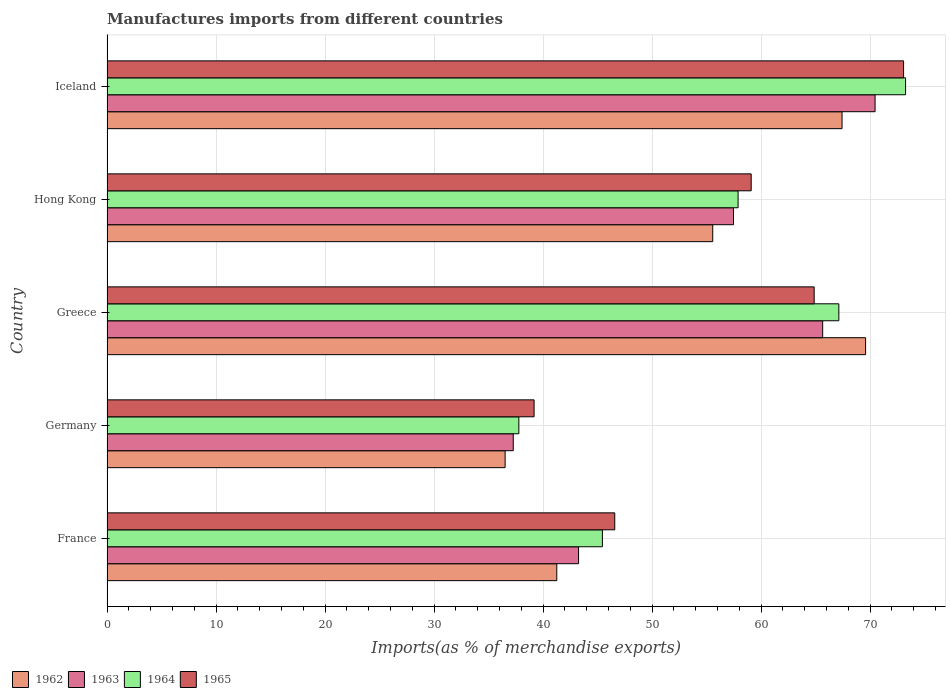How many different coloured bars are there?
Offer a very short reply. 4. How many groups of bars are there?
Provide a succinct answer. 5. Are the number of bars on each tick of the Y-axis equal?
Your response must be concise. Yes. How many bars are there on the 4th tick from the top?
Keep it short and to the point. 4. What is the label of the 2nd group of bars from the top?
Give a very brief answer. Hong Kong. What is the percentage of imports to different countries in 1965 in Hong Kong?
Ensure brevity in your answer.  59.09. Across all countries, what is the maximum percentage of imports to different countries in 1962?
Make the answer very short. 69.58. Across all countries, what is the minimum percentage of imports to different countries in 1964?
Offer a very short reply. 37.78. What is the total percentage of imports to different countries in 1962 in the graph?
Make the answer very short. 270.34. What is the difference between the percentage of imports to different countries in 1963 in Germany and that in Greece?
Keep it short and to the point. -28.38. What is the difference between the percentage of imports to different countries in 1965 in Greece and the percentage of imports to different countries in 1964 in Germany?
Your response must be concise. 27.09. What is the average percentage of imports to different countries in 1965 per country?
Give a very brief answer. 56.56. What is the difference between the percentage of imports to different countries in 1964 and percentage of imports to different countries in 1965 in Germany?
Keep it short and to the point. -1.4. What is the ratio of the percentage of imports to different countries in 1964 in Hong Kong to that in Iceland?
Give a very brief answer. 0.79. What is the difference between the highest and the second highest percentage of imports to different countries in 1962?
Make the answer very short. 2.16. What is the difference between the highest and the lowest percentage of imports to different countries in 1963?
Provide a short and direct response. 33.19. Is the sum of the percentage of imports to different countries in 1962 in France and Iceland greater than the maximum percentage of imports to different countries in 1964 across all countries?
Provide a succinct answer. Yes. Is it the case that in every country, the sum of the percentage of imports to different countries in 1963 and percentage of imports to different countries in 1962 is greater than the sum of percentage of imports to different countries in 1964 and percentage of imports to different countries in 1965?
Your answer should be compact. No. What is the difference between two consecutive major ticks on the X-axis?
Provide a succinct answer. 10. Are the values on the major ticks of X-axis written in scientific E-notation?
Ensure brevity in your answer.  No. How many legend labels are there?
Make the answer very short. 4. How are the legend labels stacked?
Keep it short and to the point. Horizontal. What is the title of the graph?
Make the answer very short. Manufactures imports from different countries. Does "1987" appear as one of the legend labels in the graph?
Provide a short and direct response. No. What is the label or title of the X-axis?
Your answer should be very brief. Imports(as % of merchandise exports). What is the Imports(as % of merchandise exports) in 1962 in France?
Your answer should be compact. 41.26. What is the Imports(as % of merchandise exports) of 1963 in France?
Your response must be concise. 43.26. What is the Imports(as % of merchandise exports) in 1964 in France?
Your answer should be very brief. 45.44. What is the Imports(as % of merchandise exports) of 1965 in France?
Your answer should be very brief. 46.57. What is the Imports(as % of merchandise exports) of 1962 in Germany?
Provide a short and direct response. 36.52. What is the Imports(as % of merchandise exports) of 1963 in Germany?
Give a very brief answer. 37.26. What is the Imports(as % of merchandise exports) in 1964 in Germany?
Provide a succinct answer. 37.78. What is the Imports(as % of merchandise exports) of 1965 in Germany?
Provide a short and direct response. 39.18. What is the Imports(as % of merchandise exports) of 1962 in Greece?
Give a very brief answer. 69.58. What is the Imports(as % of merchandise exports) of 1963 in Greece?
Keep it short and to the point. 65.65. What is the Imports(as % of merchandise exports) in 1964 in Greece?
Offer a very short reply. 67.13. What is the Imports(as % of merchandise exports) of 1965 in Greece?
Provide a short and direct response. 64.87. What is the Imports(as % of merchandise exports) in 1962 in Hong Kong?
Make the answer very short. 55.56. What is the Imports(as % of merchandise exports) in 1963 in Hong Kong?
Your answer should be compact. 57.47. What is the Imports(as % of merchandise exports) of 1964 in Hong Kong?
Ensure brevity in your answer.  57.89. What is the Imports(as % of merchandise exports) in 1965 in Hong Kong?
Provide a succinct answer. 59.09. What is the Imports(as % of merchandise exports) of 1962 in Iceland?
Provide a succinct answer. 67.42. What is the Imports(as % of merchandise exports) of 1963 in Iceland?
Offer a very short reply. 70.45. What is the Imports(as % of merchandise exports) of 1964 in Iceland?
Your answer should be compact. 73.25. What is the Imports(as % of merchandise exports) of 1965 in Iceland?
Your answer should be very brief. 73.07. Across all countries, what is the maximum Imports(as % of merchandise exports) of 1962?
Offer a very short reply. 69.58. Across all countries, what is the maximum Imports(as % of merchandise exports) in 1963?
Provide a short and direct response. 70.45. Across all countries, what is the maximum Imports(as % of merchandise exports) in 1964?
Your answer should be very brief. 73.25. Across all countries, what is the maximum Imports(as % of merchandise exports) in 1965?
Your answer should be compact. 73.07. Across all countries, what is the minimum Imports(as % of merchandise exports) in 1962?
Offer a terse response. 36.52. Across all countries, what is the minimum Imports(as % of merchandise exports) in 1963?
Provide a succinct answer. 37.26. Across all countries, what is the minimum Imports(as % of merchandise exports) of 1964?
Your response must be concise. 37.78. Across all countries, what is the minimum Imports(as % of merchandise exports) of 1965?
Offer a terse response. 39.18. What is the total Imports(as % of merchandise exports) of 1962 in the graph?
Offer a terse response. 270.34. What is the total Imports(as % of merchandise exports) in 1963 in the graph?
Your answer should be very brief. 274.09. What is the total Imports(as % of merchandise exports) of 1964 in the graph?
Your response must be concise. 281.49. What is the total Imports(as % of merchandise exports) in 1965 in the graph?
Offer a very short reply. 282.78. What is the difference between the Imports(as % of merchandise exports) of 1962 in France and that in Germany?
Your answer should be very brief. 4.74. What is the difference between the Imports(as % of merchandise exports) of 1963 in France and that in Germany?
Your response must be concise. 5.99. What is the difference between the Imports(as % of merchandise exports) in 1964 in France and that in Germany?
Give a very brief answer. 7.67. What is the difference between the Imports(as % of merchandise exports) of 1965 in France and that in Germany?
Keep it short and to the point. 7.4. What is the difference between the Imports(as % of merchandise exports) of 1962 in France and that in Greece?
Provide a succinct answer. -28.33. What is the difference between the Imports(as % of merchandise exports) in 1963 in France and that in Greece?
Make the answer very short. -22.39. What is the difference between the Imports(as % of merchandise exports) in 1964 in France and that in Greece?
Ensure brevity in your answer.  -21.69. What is the difference between the Imports(as % of merchandise exports) of 1965 in France and that in Greece?
Offer a terse response. -18.29. What is the difference between the Imports(as % of merchandise exports) in 1962 in France and that in Hong Kong?
Make the answer very short. -14.31. What is the difference between the Imports(as % of merchandise exports) in 1963 in France and that in Hong Kong?
Provide a succinct answer. -14.21. What is the difference between the Imports(as % of merchandise exports) in 1964 in France and that in Hong Kong?
Offer a terse response. -12.45. What is the difference between the Imports(as % of merchandise exports) of 1965 in France and that in Hong Kong?
Your answer should be very brief. -12.52. What is the difference between the Imports(as % of merchandise exports) of 1962 in France and that in Iceland?
Provide a short and direct response. -26.17. What is the difference between the Imports(as % of merchandise exports) of 1963 in France and that in Iceland?
Ensure brevity in your answer.  -27.2. What is the difference between the Imports(as % of merchandise exports) of 1964 in France and that in Iceland?
Offer a terse response. -27.81. What is the difference between the Imports(as % of merchandise exports) of 1965 in France and that in Iceland?
Your response must be concise. -26.49. What is the difference between the Imports(as % of merchandise exports) in 1962 in Germany and that in Greece?
Ensure brevity in your answer.  -33.06. What is the difference between the Imports(as % of merchandise exports) of 1963 in Germany and that in Greece?
Offer a terse response. -28.38. What is the difference between the Imports(as % of merchandise exports) in 1964 in Germany and that in Greece?
Provide a short and direct response. -29.35. What is the difference between the Imports(as % of merchandise exports) in 1965 in Germany and that in Greece?
Your response must be concise. -25.69. What is the difference between the Imports(as % of merchandise exports) of 1962 in Germany and that in Hong Kong?
Ensure brevity in your answer.  -19.04. What is the difference between the Imports(as % of merchandise exports) of 1963 in Germany and that in Hong Kong?
Your answer should be compact. -20.2. What is the difference between the Imports(as % of merchandise exports) in 1964 in Germany and that in Hong Kong?
Provide a short and direct response. -20.11. What is the difference between the Imports(as % of merchandise exports) of 1965 in Germany and that in Hong Kong?
Ensure brevity in your answer.  -19.91. What is the difference between the Imports(as % of merchandise exports) of 1962 in Germany and that in Iceland?
Provide a succinct answer. -30.9. What is the difference between the Imports(as % of merchandise exports) of 1963 in Germany and that in Iceland?
Provide a succinct answer. -33.19. What is the difference between the Imports(as % of merchandise exports) in 1964 in Germany and that in Iceland?
Ensure brevity in your answer.  -35.47. What is the difference between the Imports(as % of merchandise exports) of 1965 in Germany and that in Iceland?
Your response must be concise. -33.89. What is the difference between the Imports(as % of merchandise exports) of 1962 in Greece and that in Hong Kong?
Keep it short and to the point. 14.02. What is the difference between the Imports(as % of merchandise exports) in 1963 in Greece and that in Hong Kong?
Provide a short and direct response. 8.18. What is the difference between the Imports(as % of merchandise exports) in 1964 in Greece and that in Hong Kong?
Give a very brief answer. 9.24. What is the difference between the Imports(as % of merchandise exports) of 1965 in Greece and that in Hong Kong?
Provide a succinct answer. 5.78. What is the difference between the Imports(as % of merchandise exports) in 1962 in Greece and that in Iceland?
Your answer should be very brief. 2.16. What is the difference between the Imports(as % of merchandise exports) of 1963 in Greece and that in Iceland?
Your response must be concise. -4.81. What is the difference between the Imports(as % of merchandise exports) in 1964 in Greece and that in Iceland?
Ensure brevity in your answer.  -6.12. What is the difference between the Imports(as % of merchandise exports) of 1965 in Greece and that in Iceland?
Make the answer very short. -8.2. What is the difference between the Imports(as % of merchandise exports) in 1962 in Hong Kong and that in Iceland?
Provide a succinct answer. -11.86. What is the difference between the Imports(as % of merchandise exports) in 1963 in Hong Kong and that in Iceland?
Keep it short and to the point. -12.98. What is the difference between the Imports(as % of merchandise exports) in 1964 in Hong Kong and that in Iceland?
Your answer should be very brief. -15.36. What is the difference between the Imports(as % of merchandise exports) of 1965 in Hong Kong and that in Iceland?
Give a very brief answer. -13.98. What is the difference between the Imports(as % of merchandise exports) in 1962 in France and the Imports(as % of merchandise exports) in 1963 in Germany?
Give a very brief answer. 3.99. What is the difference between the Imports(as % of merchandise exports) of 1962 in France and the Imports(as % of merchandise exports) of 1964 in Germany?
Your answer should be compact. 3.48. What is the difference between the Imports(as % of merchandise exports) in 1962 in France and the Imports(as % of merchandise exports) in 1965 in Germany?
Your answer should be compact. 2.08. What is the difference between the Imports(as % of merchandise exports) in 1963 in France and the Imports(as % of merchandise exports) in 1964 in Germany?
Your answer should be compact. 5.48. What is the difference between the Imports(as % of merchandise exports) in 1963 in France and the Imports(as % of merchandise exports) in 1965 in Germany?
Your answer should be very brief. 4.08. What is the difference between the Imports(as % of merchandise exports) in 1964 in France and the Imports(as % of merchandise exports) in 1965 in Germany?
Provide a short and direct response. 6.27. What is the difference between the Imports(as % of merchandise exports) of 1962 in France and the Imports(as % of merchandise exports) of 1963 in Greece?
Provide a succinct answer. -24.39. What is the difference between the Imports(as % of merchandise exports) of 1962 in France and the Imports(as % of merchandise exports) of 1964 in Greece?
Offer a terse response. -25.87. What is the difference between the Imports(as % of merchandise exports) of 1962 in France and the Imports(as % of merchandise exports) of 1965 in Greece?
Provide a short and direct response. -23.61. What is the difference between the Imports(as % of merchandise exports) of 1963 in France and the Imports(as % of merchandise exports) of 1964 in Greece?
Keep it short and to the point. -23.87. What is the difference between the Imports(as % of merchandise exports) of 1963 in France and the Imports(as % of merchandise exports) of 1965 in Greece?
Give a very brief answer. -21.61. What is the difference between the Imports(as % of merchandise exports) of 1964 in France and the Imports(as % of merchandise exports) of 1965 in Greece?
Ensure brevity in your answer.  -19.43. What is the difference between the Imports(as % of merchandise exports) of 1962 in France and the Imports(as % of merchandise exports) of 1963 in Hong Kong?
Your answer should be compact. -16.21. What is the difference between the Imports(as % of merchandise exports) in 1962 in France and the Imports(as % of merchandise exports) in 1964 in Hong Kong?
Ensure brevity in your answer.  -16.63. What is the difference between the Imports(as % of merchandise exports) in 1962 in France and the Imports(as % of merchandise exports) in 1965 in Hong Kong?
Offer a terse response. -17.83. What is the difference between the Imports(as % of merchandise exports) of 1963 in France and the Imports(as % of merchandise exports) of 1964 in Hong Kong?
Your answer should be very brief. -14.63. What is the difference between the Imports(as % of merchandise exports) of 1963 in France and the Imports(as % of merchandise exports) of 1965 in Hong Kong?
Give a very brief answer. -15.83. What is the difference between the Imports(as % of merchandise exports) of 1964 in France and the Imports(as % of merchandise exports) of 1965 in Hong Kong?
Offer a very short reply. -13.65. What is the difference between the Imports(as % of merchandise exports) of 1962 in France and the Imports(as % of merchandise exports) of 1963 in Iceland?
Offer a very short reply. -29.2. What is the difference between the Imports(as % of merchandise exports) of 1962 in France and the Imports(as % of merchandise exports) of 1964 in Iceland?
Make the answer very short. -31.99. What is the difference between the Imports(as % of merchandise exports) in 1962 in France and the Imports(as % of merchandise exports) in 1965 in Iceland?
Your answer should be very brief. -31.81. What is the difference between the Imports(as % of merchandise exports) of 1963 in France and the Imports(as % of merchandise exports) of 1964 in Iceland?
Your answer should be very brief. -29.99. What is the difference between the Imports(as % of merchandise exports) of 1963 in France and the Imports(as % of merchandise exports) of 1965 in Iceland?
Keep it short and to the point. -29.81. What is the difference between the Imports(as % of merchandise exports) of 1964 in France and the Imports(as % of merchandise exports) of 1965 in Iceland?
Ensure brevity in your answer.  -27.63. What is the difference between the Imports(as % of merchandise exports) in 1962 in Germany and the Imports(as % of merchandise exports) in 1963 in Greece?
Keep it short and to the point. -29.13. What is the difference between the Imports(as % of merchandise exports) in 1962 in Germany and the Imports(as % of merchandise exports) in 1964 in Greece?
Give a very brief answer. -30.61. What is the difference between the Imports(as % of merchandise exports) in 1962 in Germany and the Imports(as % of merchandise exports) in 1965 in Greece?
Your answer should be compact. -28.35. What is the difference between the Imports(as % of merchandise exports) in 1963 in Germany and the Imports(as % of merchandise exports) in 1964 in Greece?
Make the answer very short. -29.87. What is the difference between the Imports(as % of merchandise exports) of 1963 in Germany and the Imports(as % of merchandise exports) of 1965 in Greece?
Your answer should be compact. -27.6. What is the difference between the Imports(as % of merchandise exports) of 1964 in Germany and the Imports(as % of merchandise exports) of 1965 in Greece?
Make the answer very short. -27.09. What is the difference between the Imports(as % of merchandise exports) in 1962 in Germany and the Imports(as % of merchandise exports) in 1963 in Hong Kong?
Offer a very short reply. -20.95. What is the difference between the Imports(as % of merchandise exports) in 1962 in Germany and the Imports(as % of merchandise exports) in 1964 in Hong Kong?
Make the answer very short. -21.37. What is the difference between the Imports(as % of merchandise exports) of 1962 in Germany and the Imports(as % of merchandise exports) of 1965 in Hong Kong?
Ensure brevity in your answer.  -22.57. What is the difference between the Imports(as % of merchandise exports) of 1963 in Germany and the Imports(as % of merchandise exports) of 1964 in Hong Kong?
Give a very brief answer. -20.62. What is the difference between the Imports(as % of merchandise exports) of 1963 in Germany and the Imports(as % of merchandise exports) of 1965 in Hong Kong?
Offer a very short reply. -21.83. What is the difference between the Imports(as % of merchandise exports) in 1964 in Germany and the Imports(as % of merchandise exports) in 1965 in Hong Kong?
Offer a very short reply. -21.31. What is the difference between the Imports(as % of merchandise exports) in 1962 in Germany and the Imports(as % of merchandise exports) in 1963 in Iceland?
Provide a short and direct response. -33.93. What is the difference between the Imports(as % of merchandise exports) in 1962 in Germany and the Imports(as % of merchandise exports) in 1964 in Iceland?
Your response must be concise. -36.73. What is the difference between the Imports(as % of merchandise exports) in 1962 in Germany and the Imports(as % of merchandise exports) in 1965 in Iceland?
Offer a terse response. -36.55. What is the difference between the Imports(as % of merchandise exports) of 1963 in Germany and the Imports(as % of merchandise exports) of 1964 in Iceland?
Ensure brevity in your answer.  -35.99. What is the difference between the Imports(as % of merchandise exports) in 1963 in Germany and the Imports(as % of merchandise exports) in 1965 in Iceland?
Provide a short and direct response. -35.8. What is the difference between the Imports(as % of merchandise exports) of 1964 in Germany and the Imports(as % of merchandise exports) of 1965 in Iceland?
Offer a terse response. -35.29. What is the difference between the Imports(as % of merchandise exports) of 1962 in Greece and the Imports(as % of merchandise exports) of 1963 in Hong Kong?
Your answer should be very brief. 12.12. What is the difference between the Imports(as % of merchandise exports) of 1962 in Greece and the Imports(as % of merchandise exports) of 1964 in Hong Kong?
Make the answer very short. 11.7. What is the difference between the Imports(as % of merchandise exports) in 1962 in Greece and the Imports(as % of merchandise exports) in 1965 in Hong Kong?
Your response must be concise. 10.49. What is the difference between the Imports(as % of merchandise exports) of 1963 in Greece and the Imports(as % of merchandise exports) of 1964 in Hong Kong?
Offer a very short reply. 7.76. What is the difference between the Imports(as % of merchandise exports) in 1963 in Greece and the Imports(as % of merchandise exports) in 1965 in Hong Kong?
Provide a succinct answer. 6.56. What is the difference between the Imports(as % of merchandise exports) of 1964 in Greece and the Imports(as % of merchandise exports) of 1965 in Hong Kong?
Your response must be concise. 8.04. What is the difference between the Imports(as % of merchandise exports) of 1962 in Greece and the Imports(as % of merchandise exports) of 1963 in Iceland?
Offer a terse response. -0.87. What is the difference between the Imports(as % of merchandise exports) in 1962 in Greece and the Imports(as % of merchandise exports) in 1964 in Iceland?
Your answer should be very brief. -3.67. What is the difference between the Imports(as % of merchandise exports) of 1962 in Greece and the Imports(as % of merchandise exports) of 1965 in Iceland?
Offer a terse response. -3.48. What is the difference between the Imports(as % of merchandise exports) of 1963 in Greece and the Imports(as % of merchandise exports) of 1964 in Iceland?
Provide a short and direct response. -7.6. What is the difference between the Imports(as % of merchandise exports) of 1963 in Greece and the Imports(as % of merchandise exports) of 1965 in Iceland?
Give a very brief answer. -7.42. What is the difference between the Imports(as % of merchandise exports) in 1964 in Greece and the Imports(as % of merchandise exports) in 1965 in Iceland?
Keep it short and to the point. -5.94. What is the difference between the Imports(as % of merchandise exports) of 1962 in Hong Kong and the Imports(as % of merchandise exports) of 1963 in Iceland?
Offer a very short reply. -14.89. What is the difference between the Imports(as % of merchandise exports) in 1962 in Hong Kong and the Imports(as % of merchandise exports) in 1964 in Iceland?
Offer a very short reply. -17.69. What is the difference between the Imports(as % of merchandise exports) of 1962 in Hong Kong and the Imports(as % of merchandise exports) of 1965 in Iceland?
Ensure brevity in your answer.  -17.51. What is the difference between the Imports(as % of merchandise exports) in 1963 in Hong Kong and the Imports(as % of merchandise exports) in 1964 in Iceland?
Make the answer very short. -15.78. What is the difference between the Imports(as % of merchandise exports) of 1963 in Hong Kong and the Imports(as % of merchandise exports) of 1965 in Iceland?
Offer a terse response. -15.6. What is the difference between the Imports(as % of merchandise exports) in 1964 in Hong Kong and the Imports(as % of merchandise exports) in 1965 in Iceland?
Keep it short and to the point. -15.18. What is the average Imports(as % of merchandise exports) of 1962 per country?
Give a very brief answer. 54.07. What is the average Imports(as % of merchandise exports) of 1963 per country?
Give a very brief answer. 54.82. What is the average Imports(as % of merchandise exports) of 1964 per country?
Ensure brevity in your answer.  56.3. What is the average Imports(as % of merchandise exports) of 1965 per country?
Your answer should be very brief. 56.56. What is the difference between the Imports(as % of merchandise exports) of 1962 and Imports(as % of merchandise exports) of 1963 in France?
Your response must be concise. -2. What is the difference between the Imports(as % of merchandise exports) in 1962 and Imports(as % of merchandise exports) in 1964 in France?
Make the answer very short. -4.19. What is the difference between the Imports(as % of merchandise exports) in 1962 and Imports(as % of merchandise exports) in 1965 in France?
Offer a very short reply. -5.32. What is the difference between the Imports(as % of merchandise exports) of 1963 and Imports(as % of merchandise exports) of 1964 in France?
Offer a terse response. -2.19. What is the difference between the Imports(as % of merchandise exports) of 1963 and Imports(as % of merchandise exports) of 1965 in France?
Your answer should be compact. -3.32. What is the difference between the Imports(as % of merchandise exports) of 1964 and Imports(as % of merchandise exports) of 1965 in France?
Provide a short and direct response. -1.13. What is the difference between the Imports(as % of merchandise exports) of 1962 and Imports(as % of merchandise exports) of 1963 in Germany?
Provide a succinct answer. -0.75. What is the difference between the Imports(as % of merchandise exports) in 1962 and Imports(as % of merchandise exports) in 1964 in Germany?
Provide a short and direct response. -1.26. What is the difference between the Imports(as % of merchandise exports) of 1962 and Imports(as % of merchandise exports) of 1965 in Germany?
Provide a short and direct response. -2.66. What is the difference between the Imports(as % of merchandise exports) in 1963 and Imports(as % of merchandise exports) in 1964 in Germany?
Make the answer very short. -0.51. What is the difference between the Imports(as % of merchandise exports) of 1963 and Imports(as % of merchandise exports) of 1965 in Germany?
Your answer should be very brief. -1.91. What is the difference between the Imports(as % of merchandise exports) in 1964 and Imports(as % of merchandise exports) in 1965 in Germany?
Give a very brief answer. -1.4. What is the difference between the Imports(as % of merchandise exports) in 1962 and Imports(as % of merchandise exports) in 1963 in Greece?
Offer a terse response. 3.94. What is the difference between the Imports(as % of merchandise exports) of 1962 and Imports(as % of merchandise exports) of 1964 in Greece?
Ensure brevity in your answer.  2.45. What is the difference between the Imports(as % of merchandise exports) of 1962 and Imports(as % of merchandise exports) of 1965 in Greece?
Provide a short and direct response. 4.72. What is the difference between the Imports(as % of merchandise exports) in 1963 and Imports(as % of merchandise exports) in 1964 in Greece?
Make the answer very short. -1.48. What is the difference between the Imports(as % of merchandise exports) in 1963 and Imports(as % of merchandise exports) in 1965 in Greece?
Offer a terse response. 0.78. What is the difference between the Imports(as % of merchandise exports) of 1964 and Imports(as % of merchandise exports) of 1965 in Greece?
Offer a very short reply. 2.26. What is the difference between the Imports(as % of merchandise exports) of 1962 and Imports(as % of merchandise exports) of 1963 in Hong Kong?
Offer a very short reply. -1.91. What is the difference between the Imports(as % of merchandise exports) of 1962 and Imports(as % of merchandise exports) of 1964 in Hong Kong?
Provide a short and direct response. -2.33. What is the difference between the Imports(as % of merchandise exports) of 1962 and Imports(as % of merchandise exports) of 1965 in Hong Kong?
Provide a succinct answer. -3.53. What is the difference between the Imports(as % of merchandise exports) in 1963 and Imports(as % of merchandise exports) in 1964 in Hong Kong?
Provide a short and direct response. -0.42. What is the difference between the Imports(as % of merchandise exports) in 1963 and Imports(as % of merchandise exports) in 1965 in Hong Kong?
Give a very brief answer. -1.62. What is the difference between the Imports(as % of merchandise exports) in 1964 and Imports(as % of merchandise exports) in 1965 in Hong Kong?
Make the answer very short. -1.2. What is the difference between the Imports(as % of merchandise exports) in 1962 and Imports(as % of merchandise exports) in 1963 in Iceland?
Give a very brief answer. -3.03. What is the difference between the Imports(as % of merchandise exports) of 1962 and Imports(as % of merchandise exports) of 1964 in Iceland?
Offer a terse response. -5.83. What is the difference between the Imports(as % of merchandise exports) of 1962 and Imports(as % of merchandise exports) of 1965 in Iceland?
Provide a succinct answer. -5.64. What is the difference between the Imports(as % of merchandise exports) in 1963 and Imports(as % of merchandise exports) in 1964 in Iceland?
Make the answer very short. -2.8. What is the difference between the Imports(as % of merchandise exports) in 1963 and Imports(as % of merchandise exports) in 1965 in Iceland?
Offer a very short reply. -2.61. What is the difference between the Imports(as % of merchandise exports) in 1964 and Imports(as % of merchandise exports) in 1965 in Iceland?
Give a very brief answer. 0.18. What is the ratio of the Imports(as % of merchandise exports) of 1962 in France to that in Germany?
Ensure brevity in your answer.  1.13. What is the ratio of the Imports(as % of merchandise exports) in 1963 in France to that in Germany?
Keep it short and to the point. 1.16. What is the ratio of the Imports(as % of merchandise exports) in 1964 in France to that in Germany?
Provide a succinct answer. 1.2. What is the ratio of the Imports(as % of merchandise exports) of 1965 in France to that in Germany?
Give a very brief answer. 1.19. What is the ratio of the Imports(as % of merchandise exports) of 1962 in France to that in Greece?
Provide a succinct answer. 0.59. What is the ratio of the Imports(as % of merchandise exports) in 1963 in France to that in Greece?
Give a very brief answer. 0.66. What is the ratio of the Imports(as % of merchandise exports) in 1964 in France to that in Greece?
Ensure brevity in your answer.  0.68. What is the ratio of the Imports(as % of merchandise exports) of 1965 in France to that in Greece?
Offer a terse response. 0.72. What is the ratio of the Imports(as % of merchandise exports) in 1962 in France to that in Hong Kong?
Your response must be concise. 0.74. What is the ratio of the Imports(as % of merchandise exports) in 1963 in France to that in Hong Kong?
Provide a short and direct response. 0.75. What is the ratio of the Imports(as % of merchandise exports) of 1964 in France to that in Hong Kong?
Provide a short and direct response. 0.79. What is the ratio of the Imports(as % of merchandise exports) of 1965 in France to that in Hong Kong?
Keep it short and to the point. 0.79. What is the ratio of the Imports(as % of merchandise exports) in 1962 in France to that in Iceland?
Offer a very short reply. 0.61. What is the ratio of the Imports(as % of merchandise exports) of 1963 in France to that in Iceland?
Your answer should be very brief. 0.61. What is the ratio of the Imports(as % of merchandise exports) in 1964 in France to that in Iceland?
Ensure brevity in your answer.  0.62. What is the ratio of the Imports(as % of merchandise exports) in 1965 in France to that in Iceland?
Ensure brevity in your answer.  0.64. What is the ratio of the Imports(as % of merchandise exports) in 1962 in Germany to that in Greece?
Give a very brief answer. 0.52. What is the ratio of the Imports(as % of merchandise exports) of 1963 in Germany to that in Greece?
Offer a very short reply. 0.57. What is the ratio of the Imports(as % of merchandise exports) of 1964 in Germany to that in Greece?
Make the answer very short. 0.56. What is the ratio of the Imports(as % of merchandise exports) in 1965 in Germany to that in Greece?
Offer a very short reply. 0.6. What is the ratio of the Imports(as % of merchandise exports) of 1962 in Germany to that in Hong Kong?
Keep it short and to the point. 0.66. What is the ratio of the Imports(as % of merchandise exports) of 1963 in Germany to that in Hong Kong?
Offer a terse response. 0.65. What is the ratio of the Imports(as % of merchandise exports) of 1964 in Germany to that in Hong Kong?
Provide a succinct answer. 0.65. What is the ratio of the Imports(as % of merchandise exports) in 1965 in Germany to that in Hong Kong?
Keep it short and to the point. 0.66. What is the ratio of the Imports(as % of merchandise exports) of 1962 in Germany to that in Iceland?
Ensure brevity in your answer.  0.54. What is the ratio of the Imports(as % of merchandise exports) of 1963 in Germany to that in Iceland?
Make the answer very short. 0.53. What is the ratio of the Imports(as % of merchandise exports) of 1964 in Germany to that in Iceland?
Provide a short and direct response. 0.52. What is the ratio of the Imports(as % of merchandise exports) in 1965 in Germany to that in Iceland?
Give a very brief answer. 0.54. What is the ratio of the Imports(as % of merchandise exports) in 1962 in Greece to that in Hong Kong?
Your response must be concise. 1.25. What is the ratio of the Imports(as % of merchandise exports) in 1963 in Greece to that in Hong Kong?
Offer a terse response. 1.14. What is the ratio of the Imports(as % of merchandise exports) of 1964 in Greece to that in Hong Kong?
Make the answer very short. 1.16. What is the ratio of the Imports(as % of merchandise exports) of 1965 in Greece to that in Hong Kong?
Your answer should be very brief. 1.1. What is the ratio of the Imports(as % of merchandise exports) of 1962 in Greece to that in Iceland?
Give a very brief answer. 1.03. What is the ratio of the Imports(as % of merchandise exports) in 1963 in Greece to that in Iceland?
Offer a very short reply. 0.93. What is the ratio of the Imports(as % of merchandise exports) of 1964 in Greece to that in Iceland?
Keep it short and to the point. 0.92. What is the ratio of the Imports(as % of merchandise exports) in 1965 in Greece to that in Iceland?
Provide a short and direct response. 0.89. What is the ratio of the Imports(as % of merchandise exports) of 1962 in Hong Kong to that in Iceland?
Keep it short and to the point. 0.82. What is the ratio of the Imports(as % of merchandise exports) of 1963 in Hong Kong to that in Iceland?
Offer a terse response. 0.82. What is the ratio of the Imports(as % of merchandise exports) of 1964 in Hong Kong to that in Iceland?
Make the answer very short. 0.79. What is the ratio of the Imports(as % of merchandise exports) of 1965 in Hong Kong to that in Iceland?
Give a very brief answer. 0.81. What is the difference between the highest and the second highest Imports(as % of merchandise exports) of 1962?
Offer a very short reply. 2.16. What is the difference between the highest and the second highest Imports(as % of merchandise exports) of 1963?
Provide a short and direct response. 4.81. What is the difference between the highest and the second highest Imports(as % of merchandise exports) of 1964?
Provide a succinct answer. 6.12. What is the difference between the highest and the second highest Imports(as % of merchandise exports) in 1965?
Make the answer very short. 8.2. What is the difference between the highest and the lowest Imports(as % of merchandise exports) of 1962?
Keep it short and to the point. 33.06. What is the difference between the highest and the lowest Imports(as % of merchandise exports) of 1963?
Give a very brief answer. 33.19. What is the difference between the highest and the lowest Imports(as % of merchandise exports) in 1964?
Ensure brevity in your answer.  35.47. What is the difference between the highest and the lowest Imports(as % of merchandise exports) in 1965?
Your answer should be compact. 33.89. 